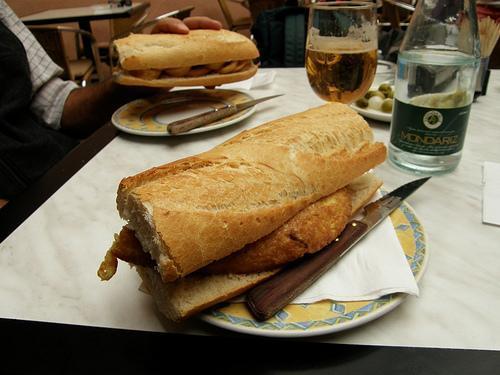How many subs?
Give a very brief answer. 2. How many people?
Give a very brief answer. 1. How many people can be seen?
Give a very brief answer. 2. How many sandwiches are there?
Give a very brief answer. 2. 